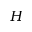Convert formula to latex. <formula><loc_0><loc_0><loc_500><loc_500>H</formula> 